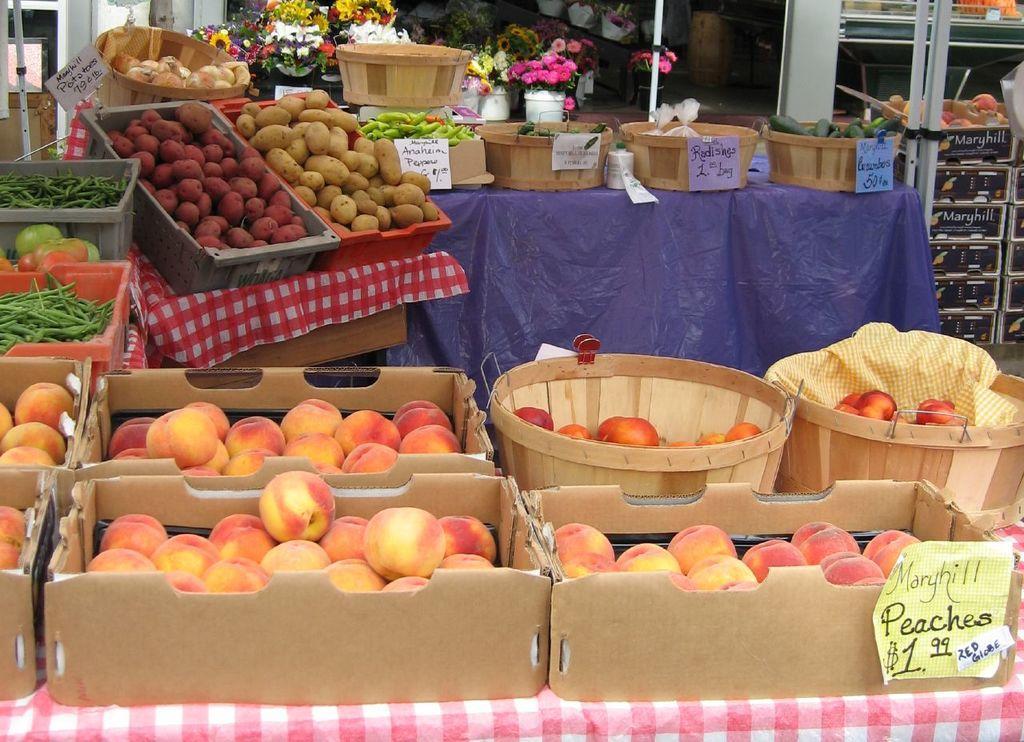Describe this image in one or two sentences. In this picture we can see some fruits, vegetables, are in the baskets, behind we can see some flower pots. 